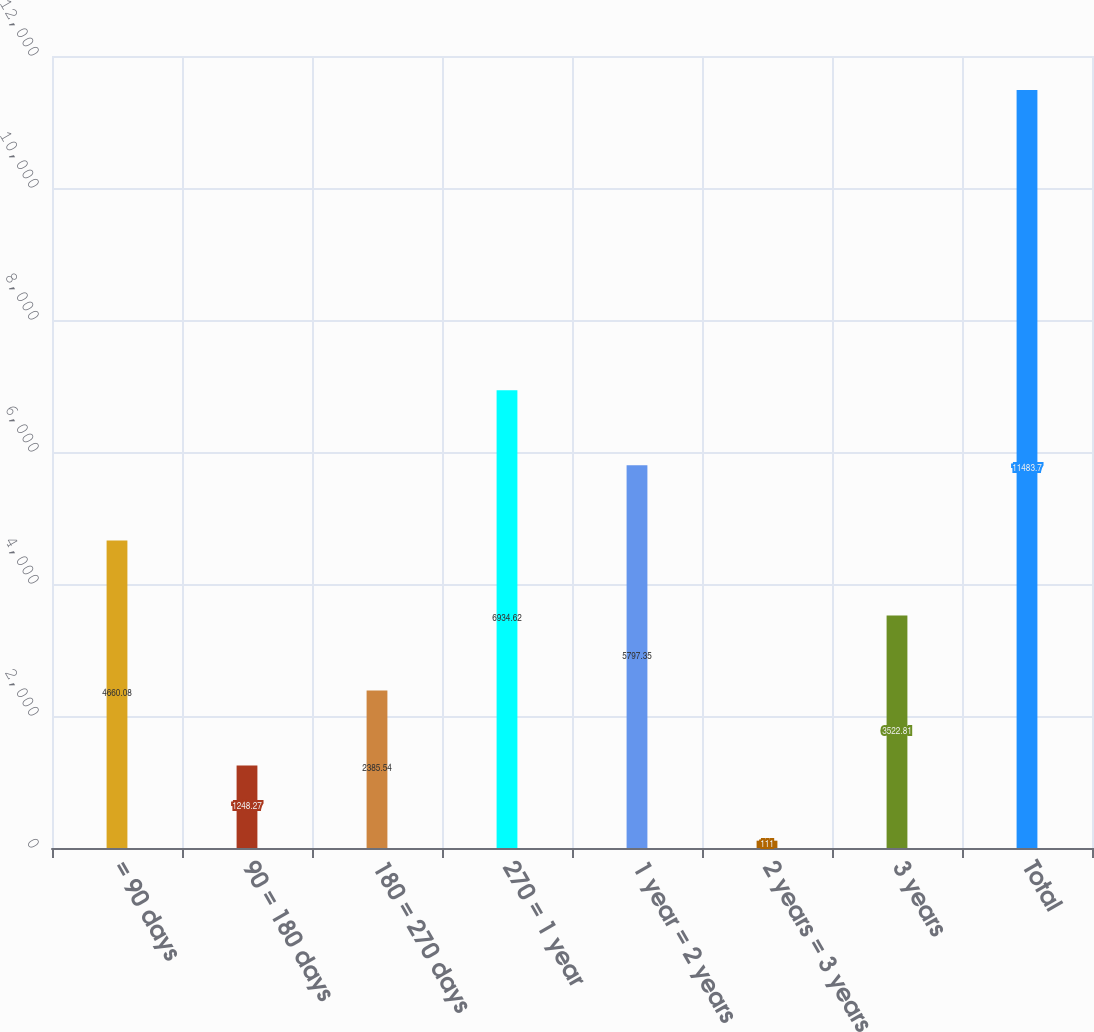<chart> <loc_0><loc_0><loc_500><loc_500><bar_chart><fcel>= 90 days<fcel>90 = 180 days<fcel>180 = 270 days<fcel>270 = 1 year<fcel>1 year = 2 years<fcel>2 years = 3 years<fcel>3 years<fcel>Total<nl><fcel>4660.08<fcel>1248.27<fcel>2385.54<fcel>6934.62<fcel>5797.35<fcel>111<fcel>3522.81<fcel>11483.7<nl></chart> 